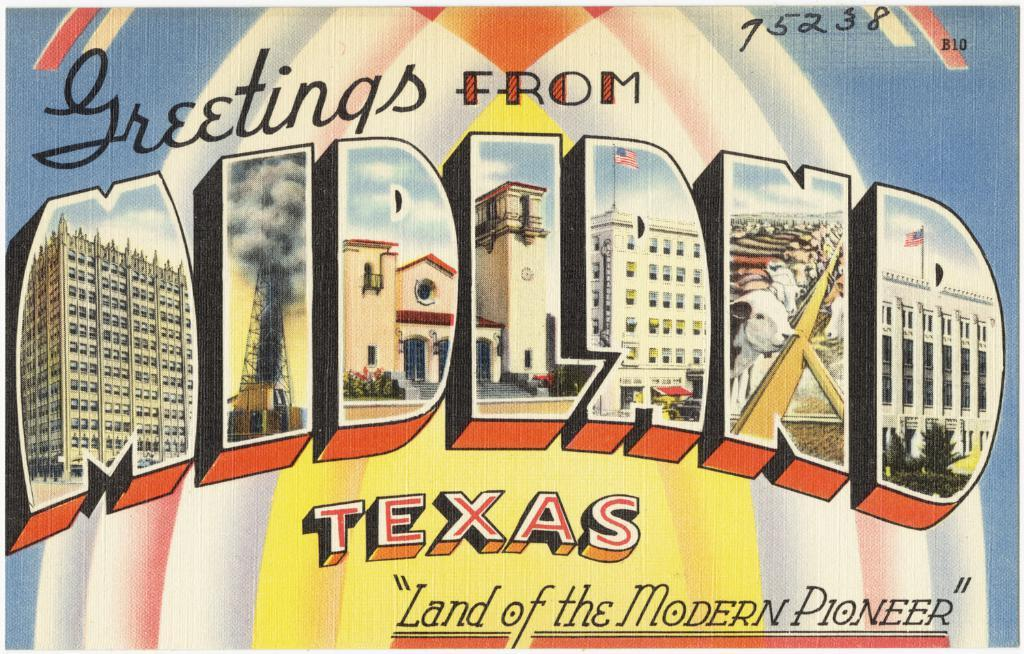<image>
Present a compact description of the photo's key features. A postcard that reads Greetings from Midland Texas. 